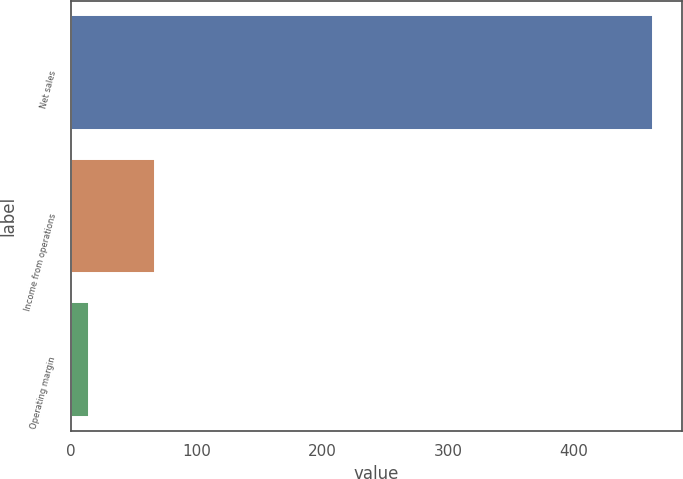Convert chart. <chart><loc_0><loc_0><loc_500><loc_500><bar_chart><fcel>Net sales<fcel>Income from operations<fcel>Operating margin<nl><fcel>463<fcel>67<fcel>14.5<nl></chart> 